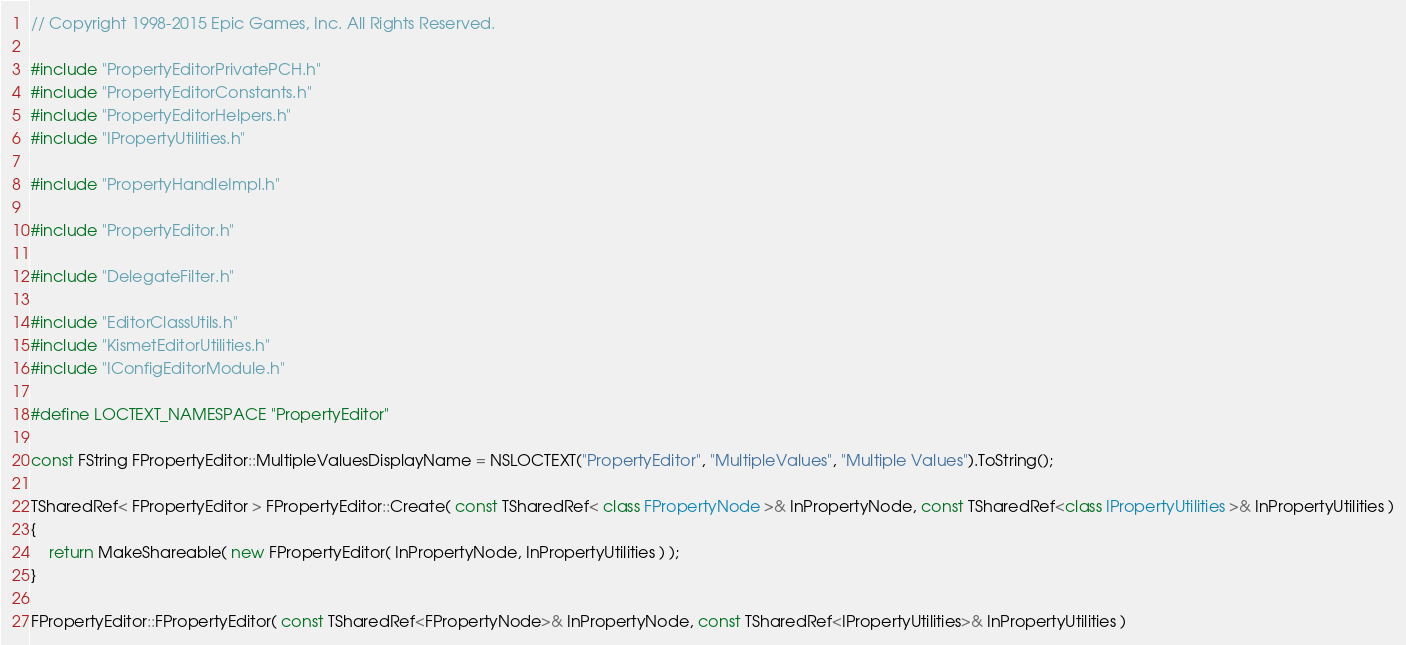Convert code to text. <code><loc_0><loc_0><loc_500><loc_500><_C++_>// Copyright 1998-2015 Epic Games, Inc. All Rights Reserved.

#include "PropertyEditorPrivatePCH.h"
#include "PropertyEditorConstants.h"
#include "PropertyEditorHelpers.h"
#include "IPropertyUtilities.h"

#include "PropertyHandleImpl.h"

#include "PropertyEditor.h"

#include "DelegateFilter.h"

#include "EditorClassUtils.h"
#include "KismetEditorUtilities.h"
#include "IConfigEditorModule.h"

#define LOCTEXT_NAMESPACE "PropertyEditor"

const FString FPropertyEditor::MultipleValuesDisplayName = NSLOCTEXT("PropertyEditor", "MultipleValues", "Multiple Values").ToString();

TSharedRef< FPropertyEditor > FPropertyEditor::Create( const TSharedRef< class FPropertyNode >& InPropertyNode, const TSharedRef<class IPropertyUtilities >& InPropertyUtilities )
{
	return MakeShareable( new FPropertyEditor( InPropertyNode, InPropertyUtilities ) );
}

FPropertyEditor::FPropertyEditor( const TSharedRef<FPropertyNode>& InPropertyNode, const TSharedRef<IPropertyUtilities>& InPropertyUtilities )</code> 